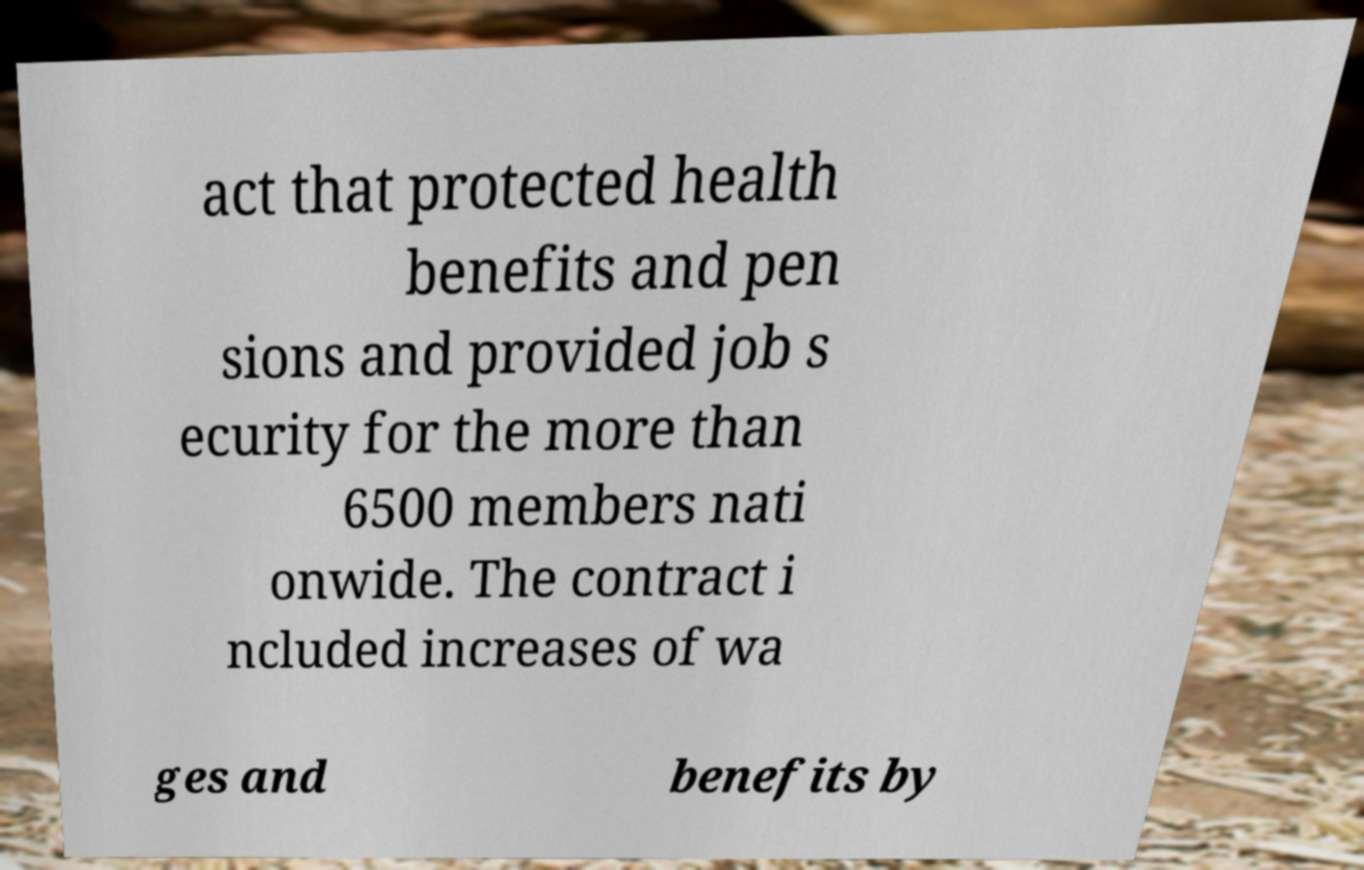Could you assist in decoding the text presented in this image and type it out clearly? act that protected health benefits and pen sions and provided job s ecurity for the more than 6500 members nati onwide. The contract i ncluded increases of wa ges and benefits by 